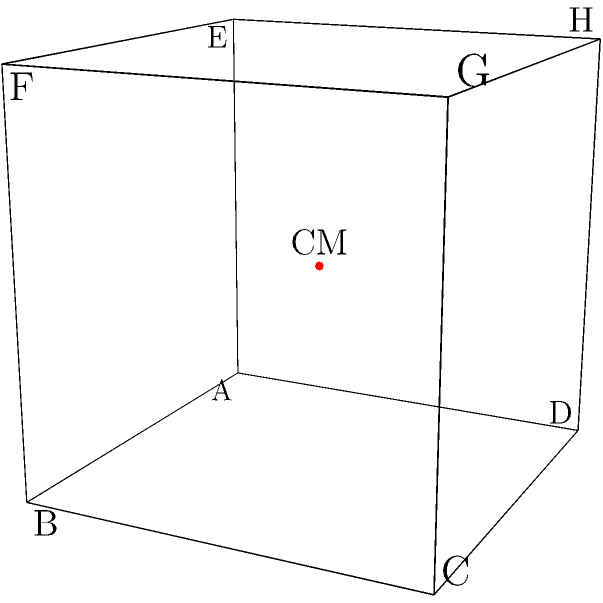In a 3D game engine, you're designing a cube-shaped object with uniform density. The cube has a side length of 2 units and its vertices are located at (0,0,0), (2,0,0), (2,2,0), (0,2,0), (0,0,2), (2,0,2), (2,2,2), and (0,2,2). What are the coordinates of the center of mass for this object? To find the center of mass for a uniform density cube, we can follow these steps:

1) For a uniform density object, the center of mass is located at the geometric center of the shape.

2) In a cube, the geometric center is at the intersection of its body diagonals.

3) To find this point, we can:
   a) Calculate the average of the x-coordinates of all vertices
   b) Calculate the average of the y-coordinates of all vertices
   c) Calculate the average of the z-coordinates of all vertices

4) Let's calculate each coordinate:

   x-coordinate: 
   $$ x = \frac{0 + 2 + 2 + 0 + 0 + 2 + 2 + 0}{8} = \frac{8}{8} = 1 $$

   y-coordinate:
   $$ y = \frac{0 + 0 + 2 + 2 + 0 + 0 + 2 + 2}{8} = \frac{8}{8} = 1 $$

   z-coordinate:
   $$ z = \frac{0 + 0 + 0 + 0 + 2 + 2 + 2 + 2}{8} = \frac{8}{8} = 1 $$

5) Therefore, the center of mass is located at (1, 1, 1).

This point is exactly in the middle of the cube, which makes sense intuitively for a uniform density object.
Answer: (1, 1, 1) 